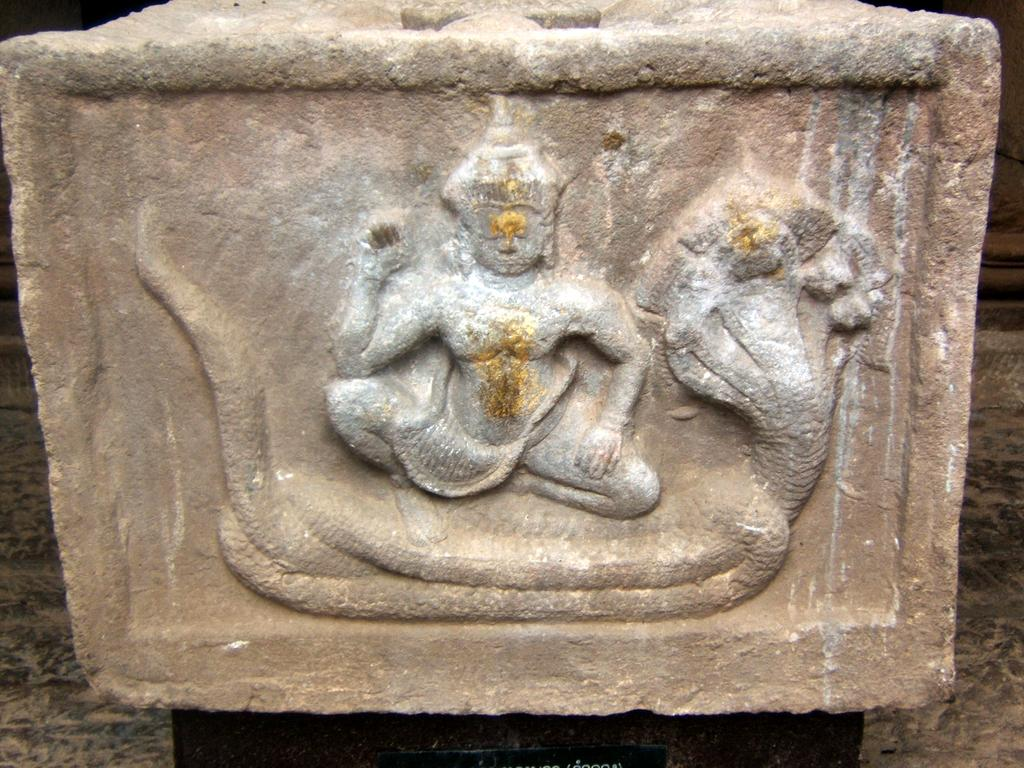What type of art is depicted in the image? There is rock-art in the image. What subjects are featured in the rock-art? The rock-art depicts a lord and a snake. Where is the rock-art located? The rock-art is on a rock. What type of meat is being prepared in the image? There is no meat present in the image; it features rock-art depicting a lord and a snake on a rock. What type of pleasure can be seen being experienced by the lord in the image? There is no indication of pleasure or any emotions being experienced by the lord in the rock-art; it is a static image. 